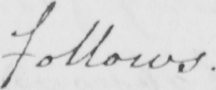Can you tell me what this handwritten text says? follows . 